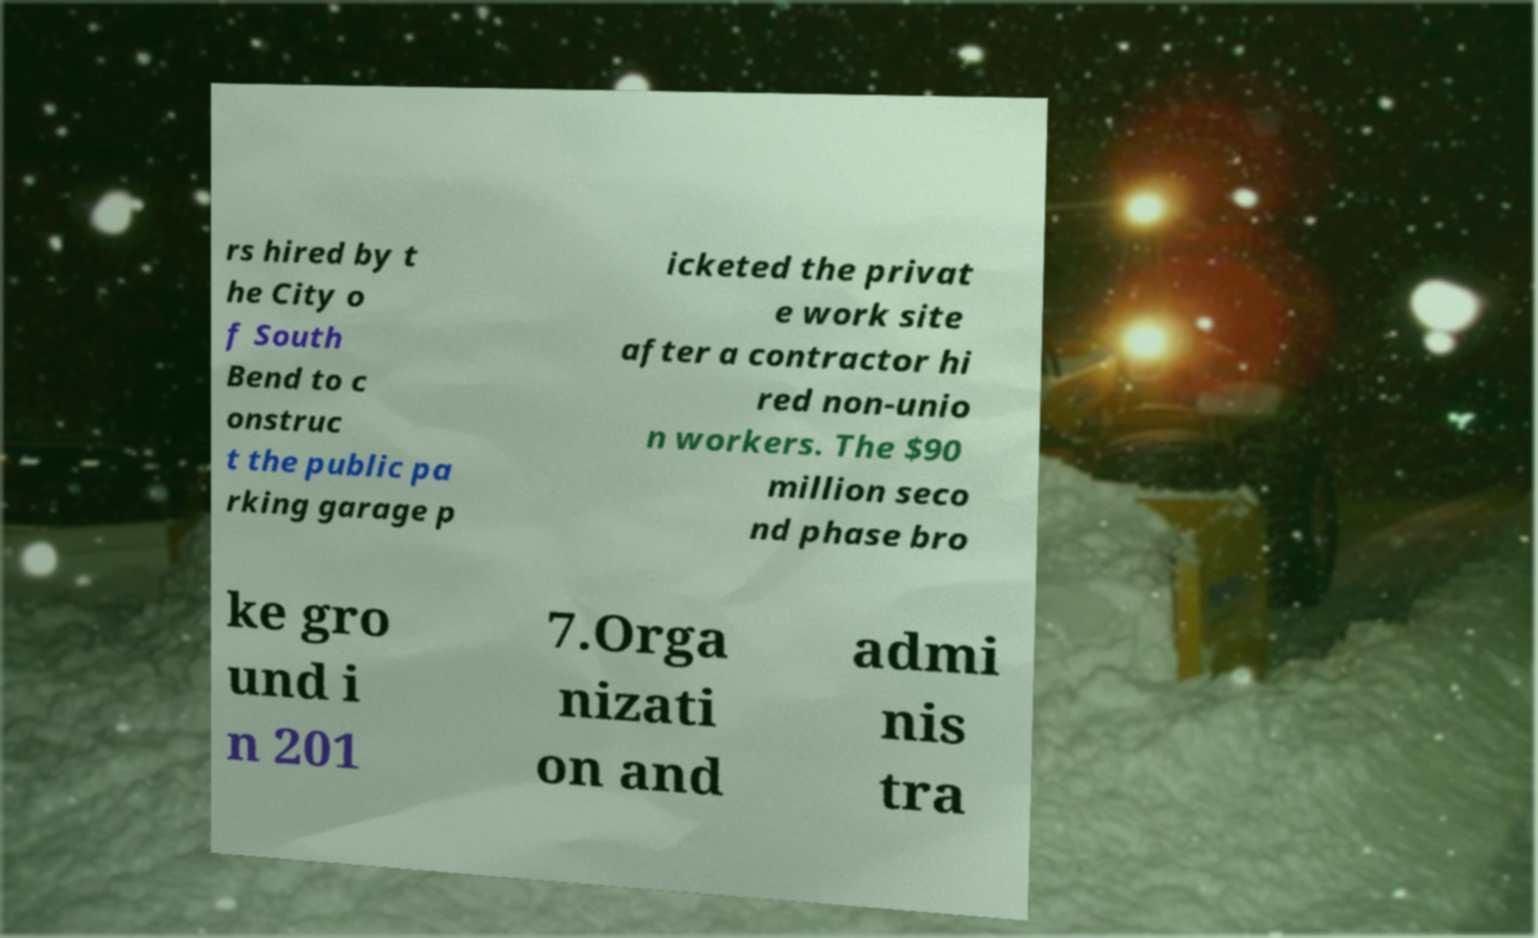For documentation purposes, I need the text within this image transcribed. Could you provide that? rs hired by t he City o f South Bend to c onstruc t the public pa rking garage p icketed the privat e work site after a contractor hi red non-unio n workers. The $90 million seco nd phase bro ke gro und i n 201 7.Orga nizati on and admi nis tra 